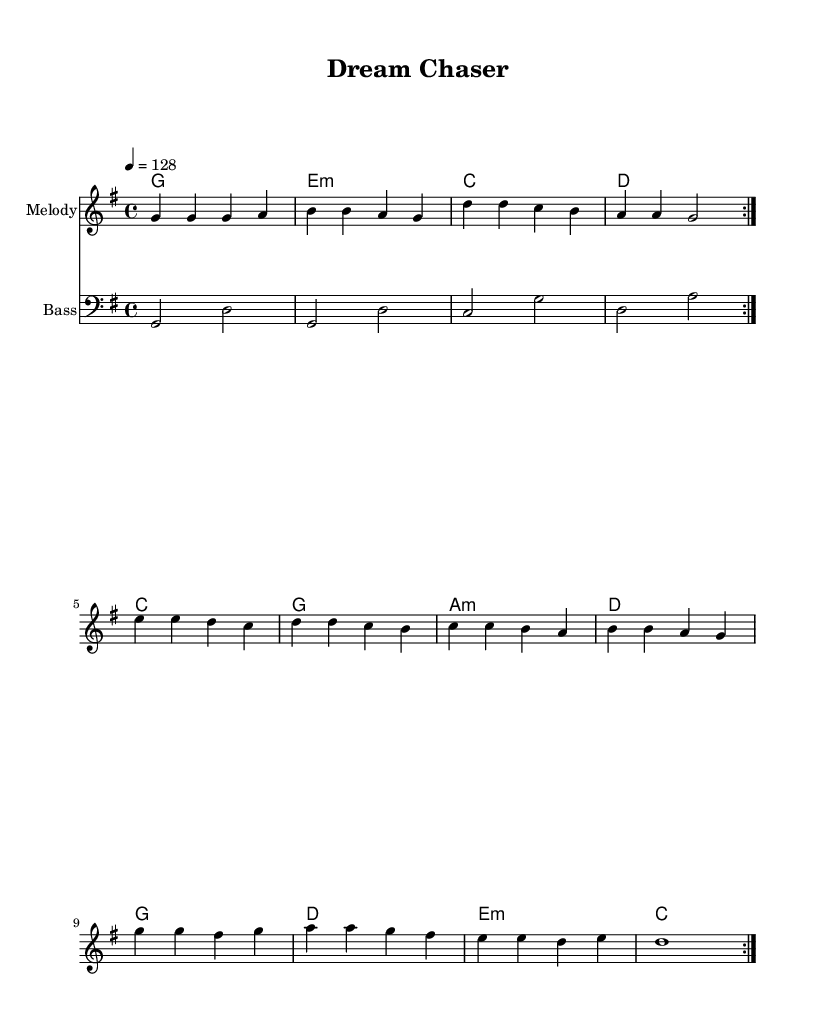What is the key signature of this music? The key signature is G major, which has one sharp (F#). You can determine the key signature by looking at the beginning of the staff where the sharps or flats are indicated. In this case, there is one sharp, which corresponds to G major.
Answer: G major What is the time signature of this piece? The time signature is 4/4, indicating four beats per measure. This can be found in the beginning of the music where the time signature is noted, meaning each measure contains four quarter-note beats.
Answer: 4/4 What is the tempo marking for this music? The tempo marking is 128 beats per minute. The tempo is indicated at the beginning of the score and specifies how fast the music should be played. In this case, it shows a metronome mark of 128.
Answer: 128 How many times is the melody repeated? The melody is repeated twice, as indicated by the "volta" marking in the score which shows that the section should be played two times. This is stated in the melody section where it says "\repeat volta 2".
Answer: 2 Which chords are used in the progression? The chords used are G, E minor, C, and D. In the harmonies section, there are four unique chords that repeat in a cycle, showing the harmonic structure of the music.
Answer: G, E minor, C, D What is the bass line starting note? The bass line starts on G. This is visible at the beginning of the bass line staff where the first note is a G note, which anchors the bass part in the tonal center.
Answer: G What theme do the lyrics of this K-Pop track reflect? The theme reflects perseverance and following dreams. This is based on K-Pop’s common lyrical content, emphasizing motivations like pursuing goals and overcoming obstacles, resonating with energetic and uplifting dance tracks.
Answer: Perseverance and following dreams 